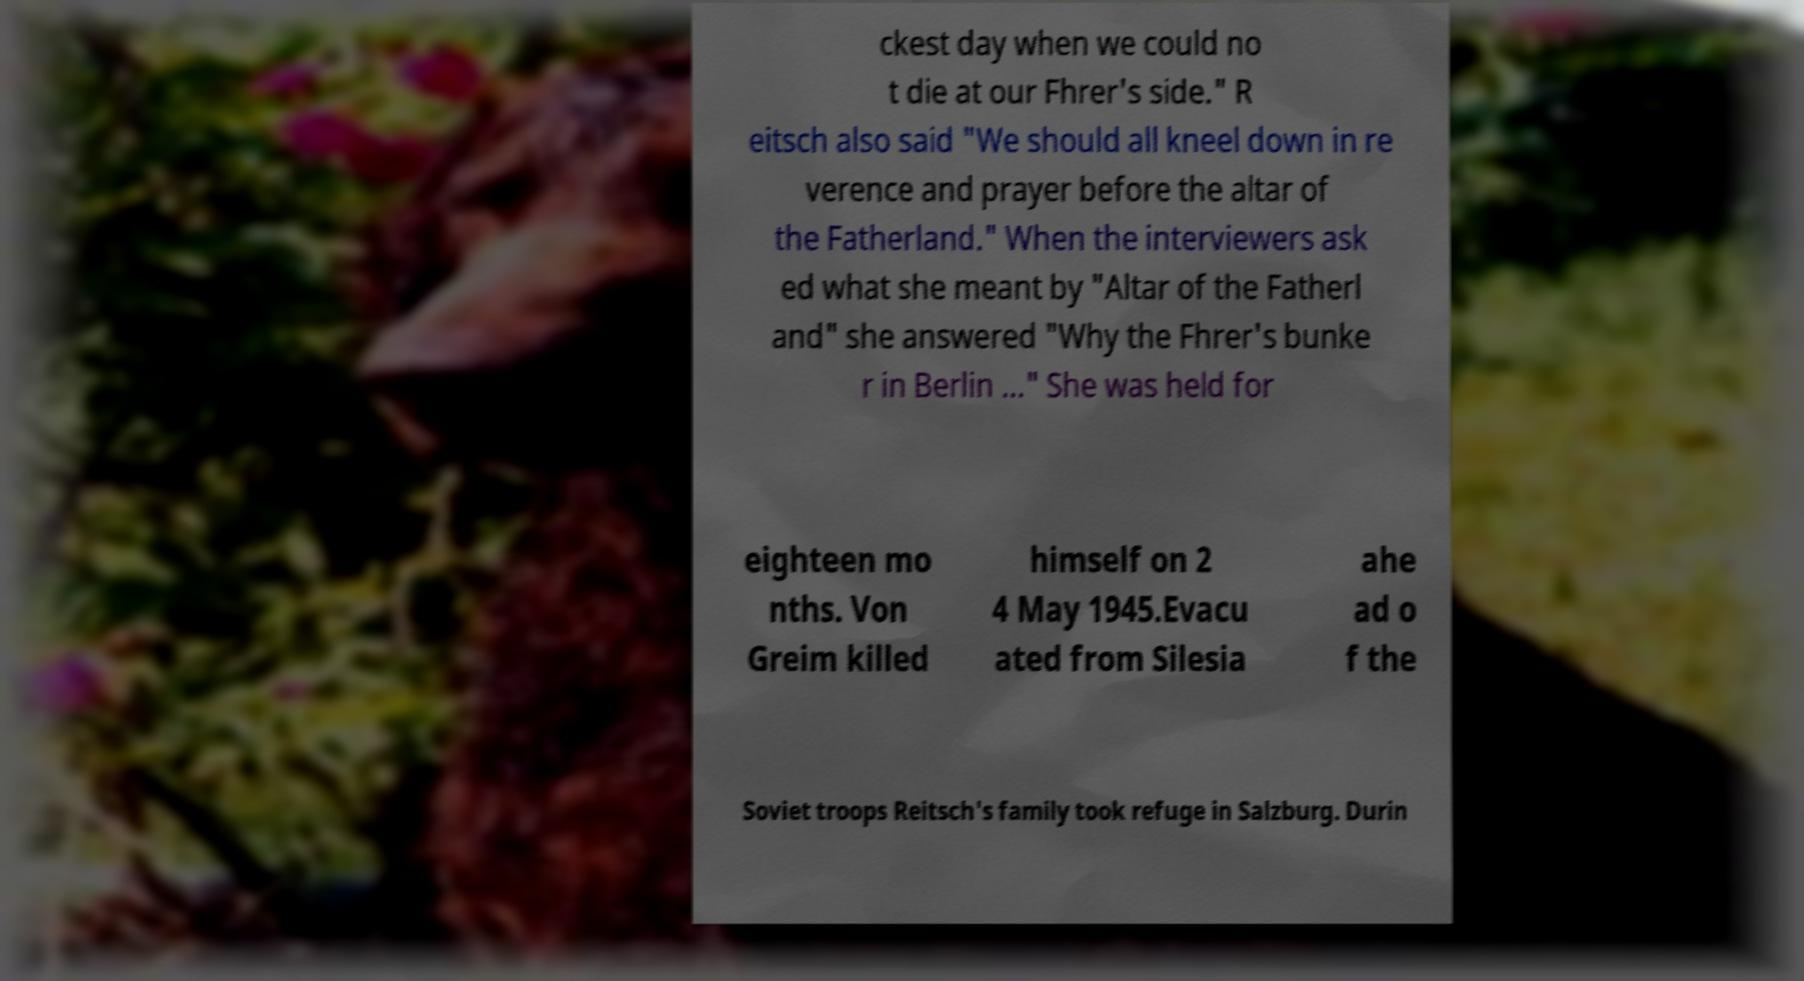Could you assist in decoding the text presented in this image and type it out clearly? ckest day when we could no t die at our Fhrer's side." R eitsch also said "We should all kneel down in re verence and prayer before the altar of the Fatherland." When the interviewers ask ed what she meant by "Altar of the Fatherl and" she answered "Why the Fhrer's bunke r in Berlin ..." She was held for eighteen mo nths. Von Greim killed himself on 2 4 May 1945.Evacu ated from Silesia ahe ad o f the Soviet troops Reitsch's family took refuge in Salzburg. Durin 